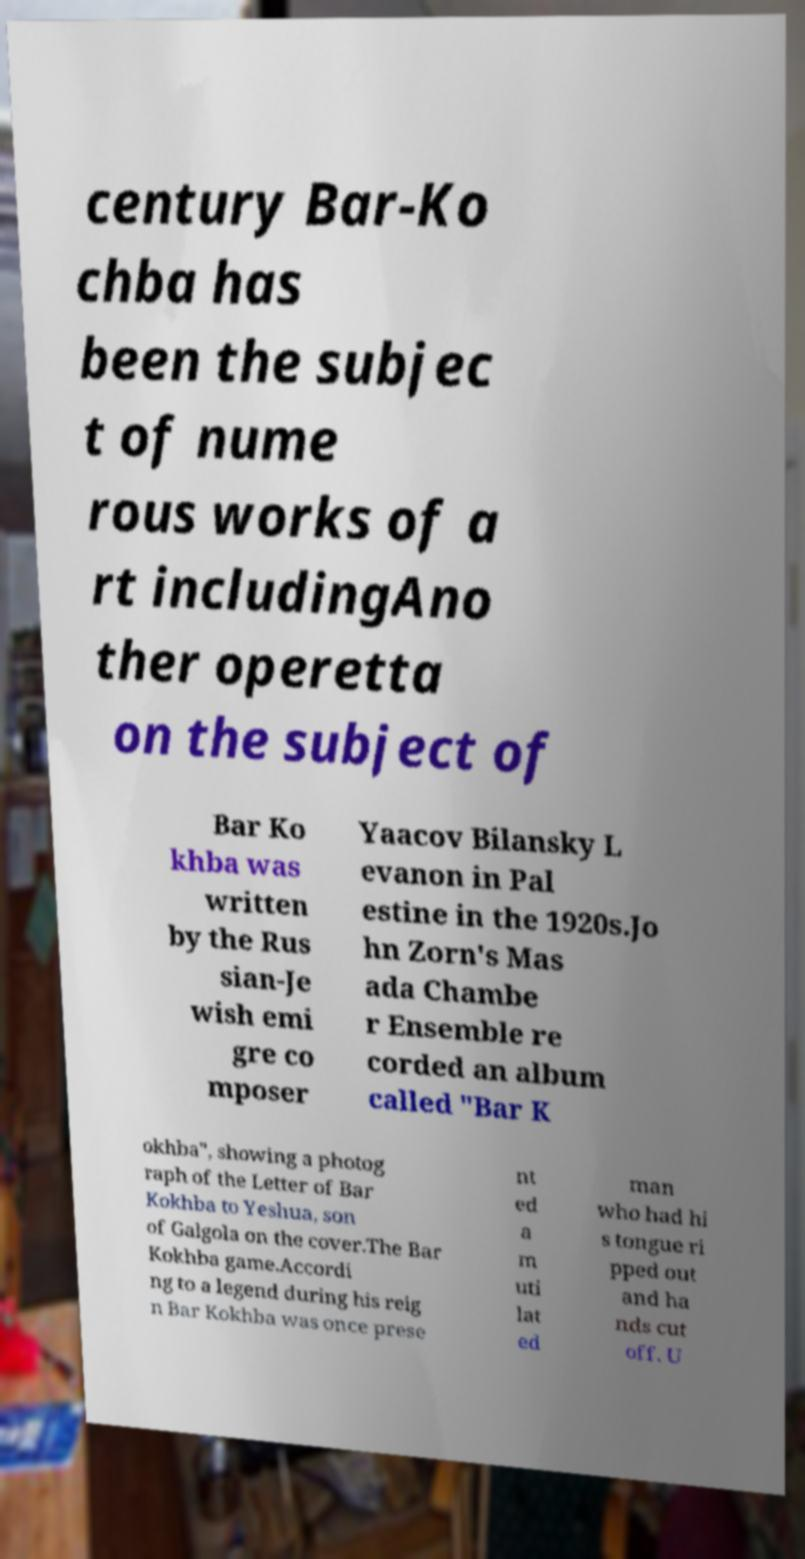Please read and relay the text visible in this image. What does it say? century Bar-Ko chba has been the subjec t of nume rous works of a rt includingAno ther operetta on the subject of Bar Ko khba was written by the Rus sian-Je wish emi gre co mposer Yaacov Bilansky L evanon in Pal estine in the 1920s.Jo hn Zorn's Mas ada Chambe r Ensemble re corded an album called "Bar K okhba", showing a photog raph of the Letter of Bar Kokhba to Yeshua, son of Galgola on the cover.The Bar Kokhba game.Accordi ng to a legend during his reig n Bar Kokhba was once prese nt ed a m uti lat ed man who had hi s tongue ri pped out and ha nds cut off. U 